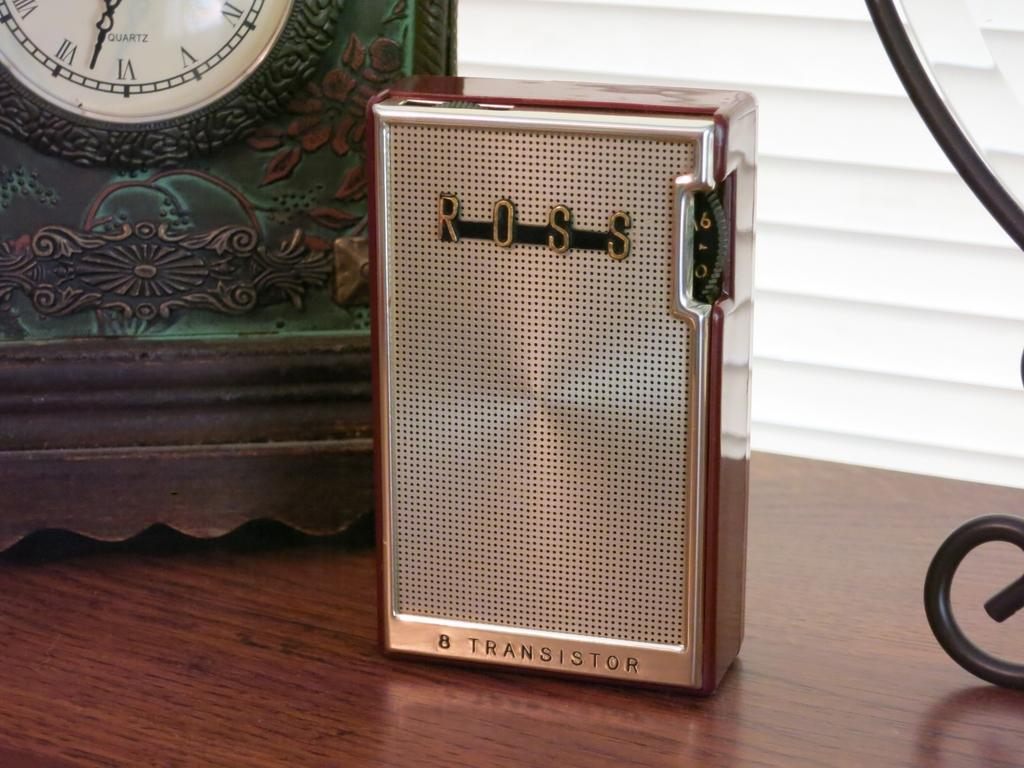What is located at the bottom of the image? There is a table at the bottom of the image. What electronic device can be seen on the table? There is a transistor on the table. What time-telling device is present on the table? There is a clock on the table. What is used to support or hold something on the table? There is a stand on the table. What shape is the protest taking in the image? There is no protest present in the image; it only features a table with a transistor, clock, and stand. 